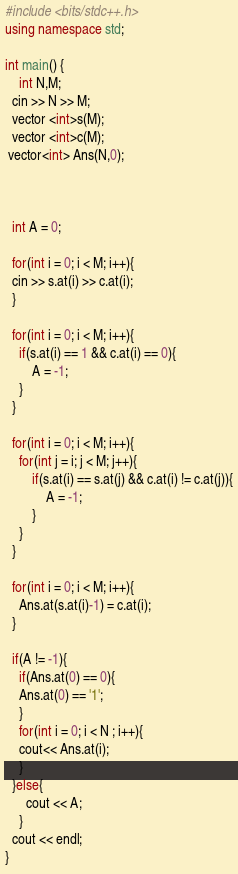Convert code to text. <code><loc_0><loc_0><loc_500><loc_500><_C++_>#include <bits/stdc++.h>
using namespace std;

int main() {
	int N,M;
  cin >> N >> M;
  vector <int>s(M);
  vector <int>c(M);
 vector<int> Ans(N,0);
  
  
  
  int A = 0;
  
  for(int i = 0; i < M; i++){
  cin >> s.at(i) >> c.at(i);
  }
  
  for(int i = 0; i < M; i++){
  	if(s.at(i) == 1 && c.at(i) == 0){
  		A = -1;
    }
  }
  
  for(int i = 0; i < M; i++){
    for(int j = i; j < M; j++){
  		if(s.at(i) == s.at(j) && c.at(i) != c.at(j)){
  			A = -1;
    	}
    }
  }
  
  for(int i = 0; i < M; i++){
  	Ans.at(s.at(i)-1) = c.at(i);
  }
  
  if(A != -1){
    if(Ans.at(0) == 0){
    Ans.at(0) == '1';
    }
  	for(int i = 0; i < N ; i++){
  	cout<< Ans.at(i);
    }
  }else{
      cout << A;
    }
  cout << endl;
}
</code> 